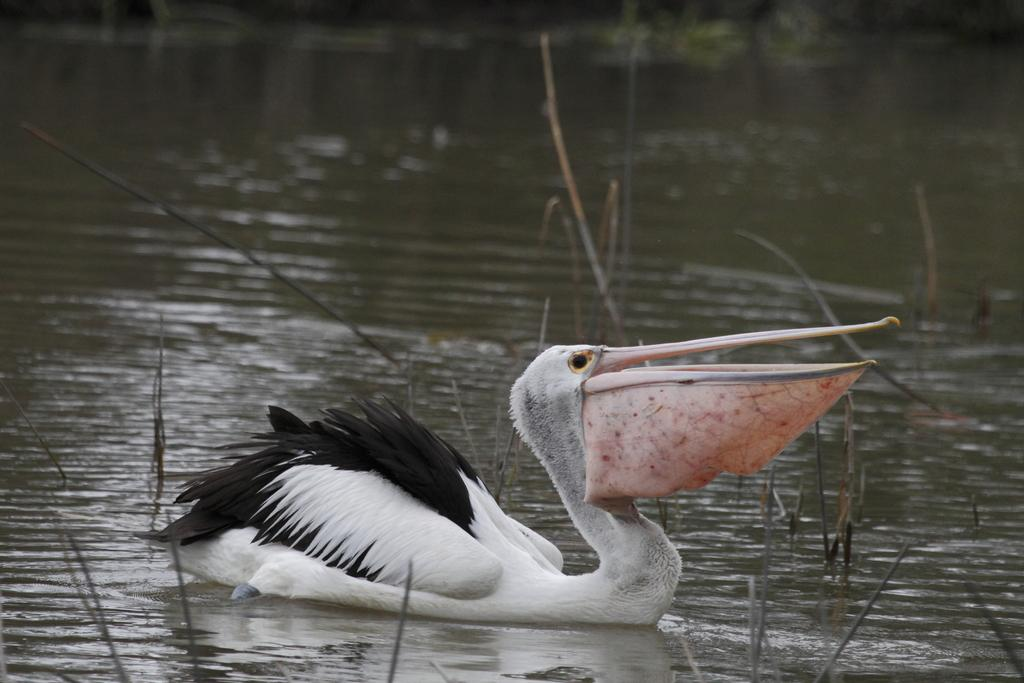What is the main subject in the center of the image? There is a bird in the center of the image. Where is the bird located? The bird is on the water. What type of linen can be seen being used by the bird in the image? There is no linen present in the image, and the bird is not using any linen. What kind of cloud can be seen in the image? There is no cloud visible in the image; it features a bird on the water. 